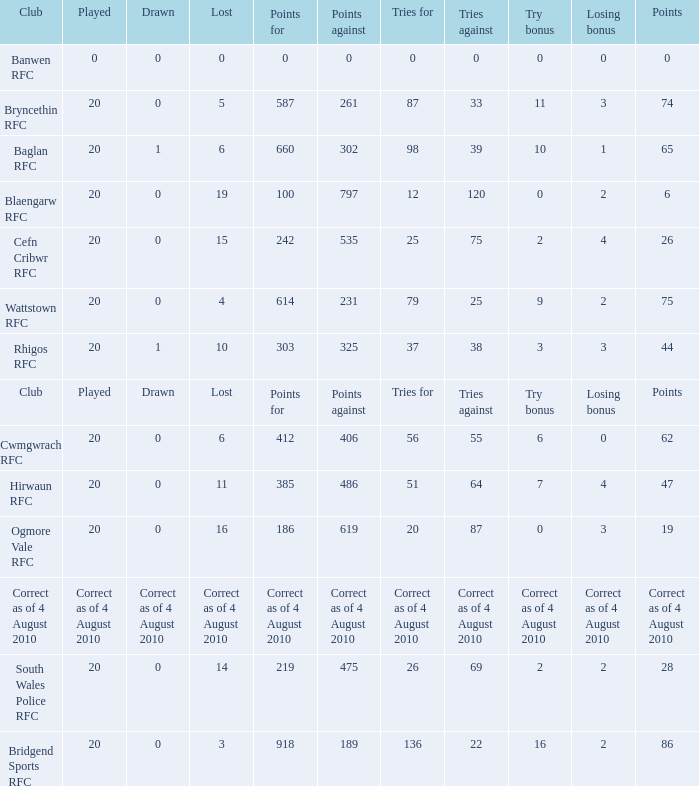What is the tries fow when losing bonus is losing bonus? Tries for. 